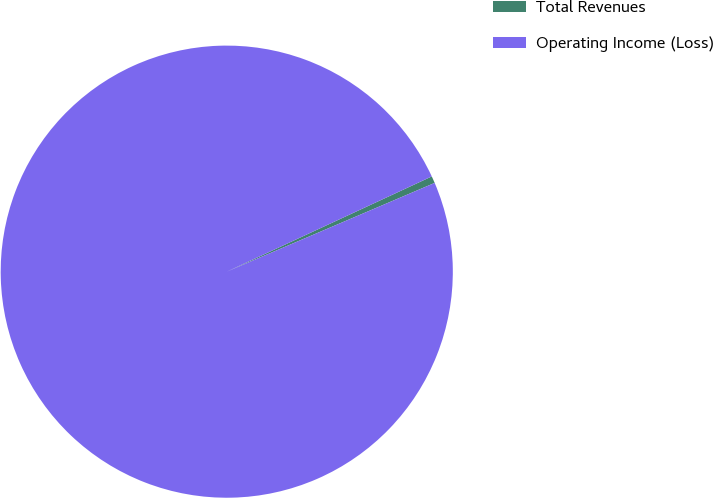<chart> <loc_0><loc_0><loc_500><loc_500><pie_chart><fcel>Total Revenues<fcel>Operating Income (Loss)<nl><fcel>0.5%<fcel>99.5%<nl></chart> 